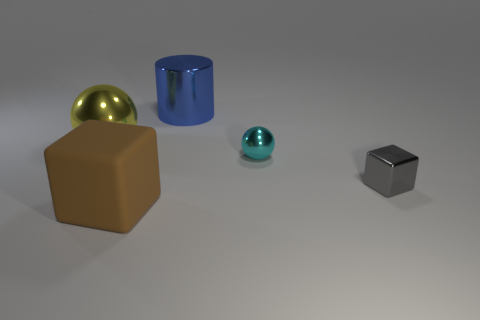Is the number of matte objects that are in front of the brown matte object greater than the number of tiny shiny cubes that are on the left side of the large blue metal cylinder?
Your answer should be compact. No. Is the shape of the big metallic thing left of the brown matte block the same as the tiny shiny thing that is to the right of the small cyan sphere?
Provide a short and direct response. No. What number of other objects are there of the same size as the blue metal thing?
Keep it short and to the point. 2. The blue cylinder has what size?
Give a very brief answer. Large. Does the sphere in front of the yellow shiny thing have the same material as the brown thing?
Ensure brevity in your answer.  No. What is the color of the small shiny object that is the same shape as the big yellow object?
Keep it short and to the point. Cyan. Is the color of the sphere that is to the left of the large blue cylinder the same as the cylinder?
Give a very brief answer. No. Are there any tiny gray blocks on the left side of the cylinder?
Give a very brief answer. No. There is a object that is both behind the brown matte cube and on the left side of the large cylinder; what color is it?
Provide a short and direct response. Yellow. What is the size of the metallic thing that is behind the metallic sphere that is on the left side of the shiny cylinder?
Your answer should be very brief. Large. 